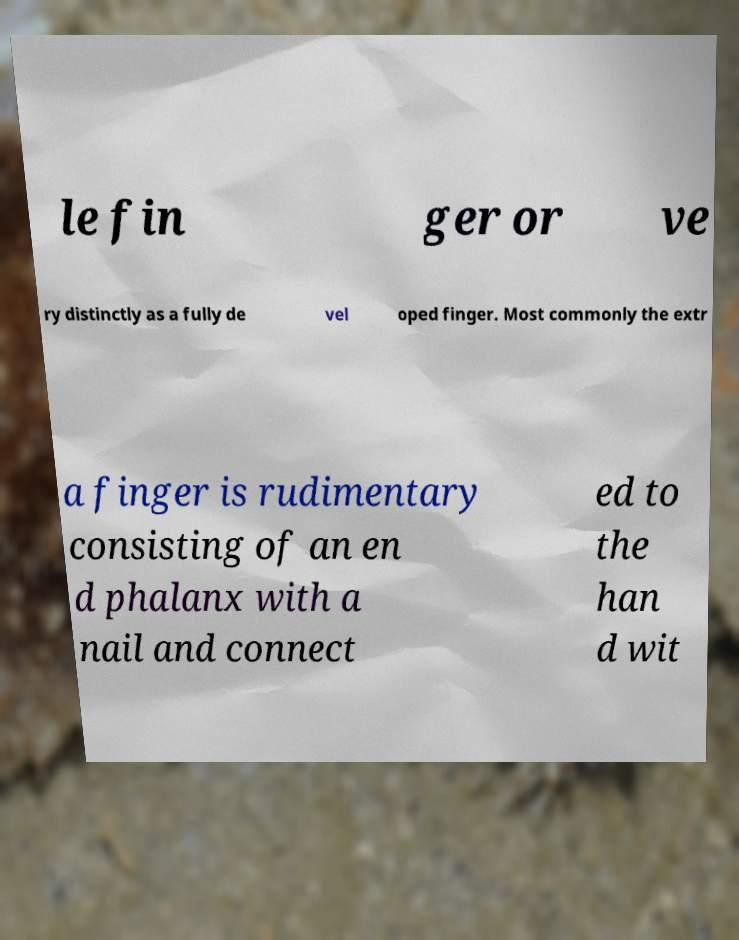For documentation purposes, I need the text within this image transcribed. Could you provide that? le fin ger or ve ry distinctly as a fully de vel oped finger. Most commonly the extr a finger is rudimentary consisting of an en d phalanx with a nail and connect ed to the han d wit 